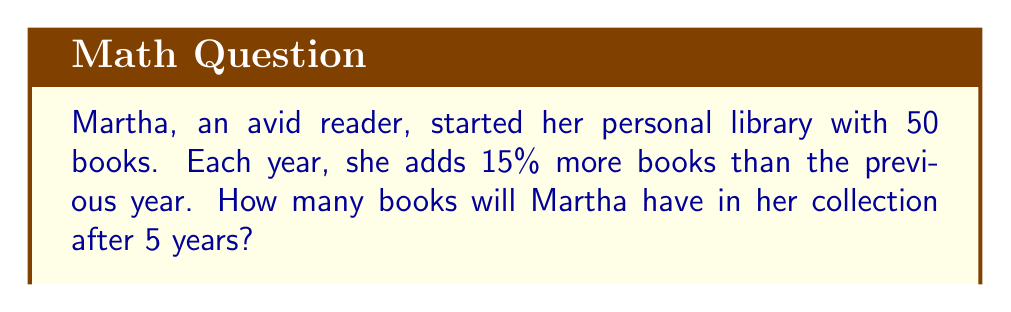Teach me how to tackle this problem. Let's approach this step-by-step:

1) First, we need to understand that Martha's library grows by 15% each year. This means we multiply the number of books by 1.15 each year.

2) We can express this mathematically as:
   $50 * (1.15)^5$

   Where 50 is the initial number of books, 1.15 represents the 15% increase (1 + 0.15), and 5 is the number of years.

3) Let's calculate this:
   $50 * (1.15)^5 = 50 * 2.0113689$

4) Now, let's multiply:
   $50 * 2.0113689 = 100.568445$

5) Since we can't have a fraction of a book, we round to the nearest whole number:
   $100.568445 \approx 101$

Therefore, after 5 years, Martha will have approximately 101 books in her collection.
Answer: 101 books 